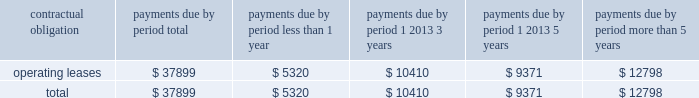As of december 31 , 2006 , we also leased an office and laboratory facility in connecticut , additional office , distribution and storage facilities in san diego , and four foreign facilities located in japan , singapore , china and the netherlands under non-cancelable operating leases that expire at various times through july 2011 .
These leases contain renewal options ranging from one to five years .
As of december 31 , 2006 , our contractual obligations were ( in thousands ) : contractual obligation total less than 1 year 1 2013 3 years 1 2013 5 years more than 5 years .
The above table does not include orders for goods and services entered into in the normal course of business that are not enforceable or legally binding .
Item 7a .
Quantitative and qualitative disclosures about market risk .
Interest rate sensitivity our exposure to market risk for changes in interest rates relates primarily to our investment portfolio .
The fair market value of fixed rate securities may be adversely impacted by fluctuations in interest rates while income earned on floating rate securities may decline as a result of decreases in interest rates .
Under our current policies , we do not use interest rate derivative instruments to manage exposure to interest rate changes .
We attempt to ensure the safety and preservation of our invested principal funds by limiting default risk , market risk and reinvestment risk .
We mitigate default risk by investing in investment grade securities .
We have historically maintained a relatively short average maturity for our investment portfolio , and we believe a hypothetical 100 basis point adverse move in interest rates along the entire interest rate yield curve would not materially affect the fair value of our interest sensitive financial instruments .
Foreign currency exchange risk although most of our revenue is realized in u.s .
Dollars , some portions of our revenue are realized in foreign currencies .
As a result , our financial results could be affected by factors such as changes in foreign currency exchange rates or weak economic conditions in foreign markets .
The functional currencies of our subsidiaries are their respective local currencies .
Accordingly , the accounts of these operations are translated from the local currency to the u.s .
Dollar using the current exchange rate in effect at the balance sheet date for the balance sheet accounts , and using the average exchange rate during the period for revenue and expense accounts .
The effects of translation are recorded in accumulated other comprehensive income as a separate component of stockholders 2019 equity. .
What is the percent of the operating leases that are due in less than year to the total leases .? 
Computations: (5320 / 37899)
Answer: 0.14037. 